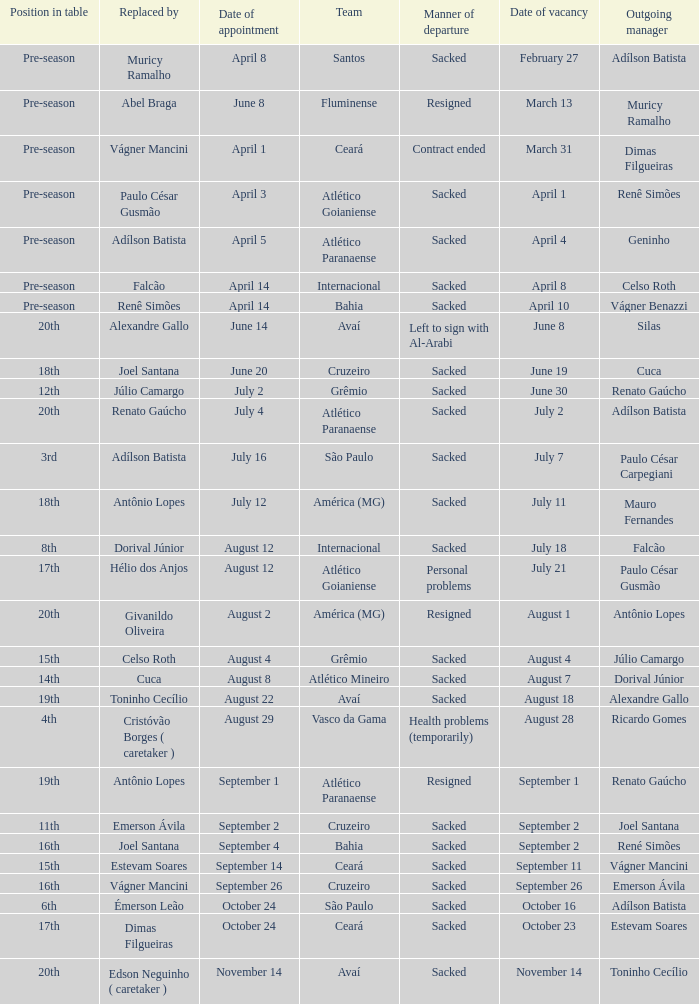What team hired Renato Gaúcho? Atlético Paranaense. 